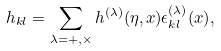Convert formula to latex. <formula><loc_0><loc_0><loc_500><loc_500>h _ { k l } = \sum _ { \lambda = + , \times } h ^ { ( \lambda ) } ( \eta , { x } ) \epsilon _ { k l } ^ { ( \lambda ) } ( { x } ) ,</formula> 